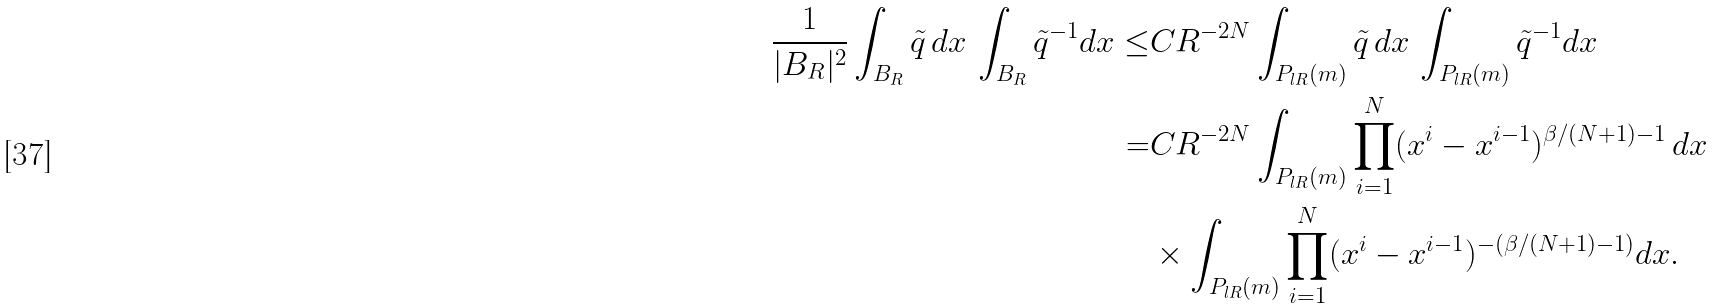Convert formula to latex. <formula><loc_0><loc_0><loc_500><loc_500>\frac { 1 } { | B _ { R } | ^ { 2 } } \int _ { B _ { R } } \tilde { q } \, d x \, \int _ { B _ { R } } \tilde { q } ^ { - 1 } d x \leq & C R ^ { - 2 N } \int _ { P _ { l R } ( m ) } \tilde { q } \, d x \, \int _ { P _ { l R } ( m ) } \tilde { q } ^ { - 1 } d x \\ = & C R ^ { - 2 N } \int _ { P _ { l R } ( m ) } \prod _ { i = 1 } ^ { N } ( x ^ { i } - x ^ { i - 1 } ) ^ { \beta / ( N + 1 ) - 1 } \, d x \\ & \times \int _ { P _ { l R } ( m ) } \prod _ { i = 1 } ^ { N } ( x ^ { i } - x ^ { i - 1 } ) ^ { - ( \beta / ( N + 1 ) - 1 ) } d x .</formula> 